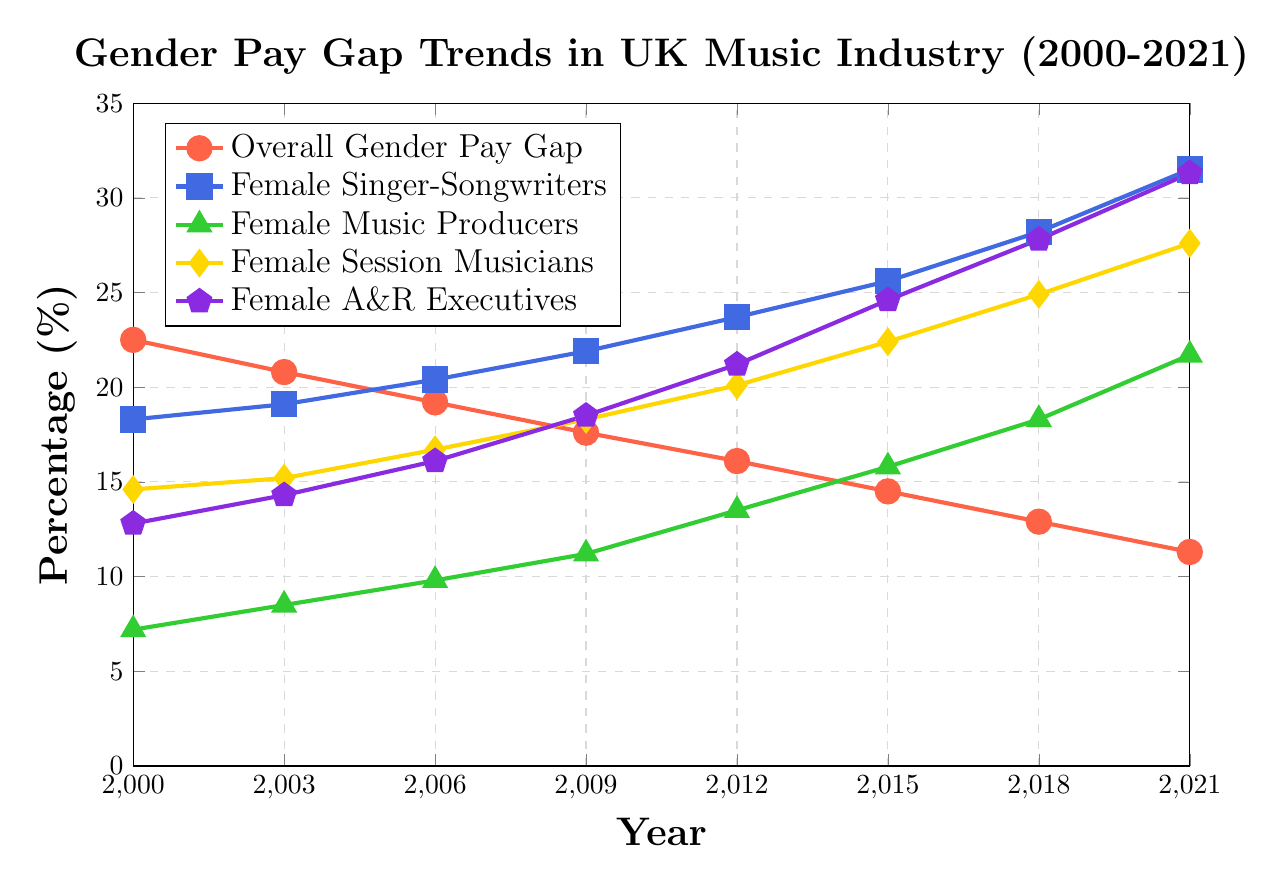What trend is observed for the Overall Gender Pay Gap from 2000 to 2021? The Overall Gender Pay Gap percentage is observed to decrease continuously from 22.5% in 2000 to 11.3% in 2021.
Answer: Decreasing trend How did the percentage of Female Music Producers change between 2000 and 2021? The percentage of Female Music Producers increased from 7.2% in 2000 to 21.7% in 2021.
Answer: Increased Compare the percentage of Female Singer-Songwriters and Female A&R Executives in 2021. Which category has a higher percentage? In 2021, the percentage of Female Singer-Songwriters is 31.5%, while the percentage of Female A&R Executives is 31.3%. Female Singer-Songwriters have a higher percentage.
Answer: Female Singer-Songwriters What is the difference in the percentage of Female Session Musicians between 2000 and 2021? The percentage of Female Session Musicians increased from 14.6% in 2000 to 27.6% in 2021. The difference is 27.6% - 14.6% = 13%.
Answer: 13% In which year did the percentage of Female A&R Executives exceed 20%? The percentage of Female A&R Executives first exceeded 20% in the year 2012.
Answer: 2012 Which category showed the largest increase in percentage from 2000 to 2021? To find the largest increase, calculate the difference for each category between 2000 and 2021:
- Female Singer-Songwriters: 31.5% - 18.3% = 13.2%
- Female Music Producers: 21.7% - 7.2% = 14.5%
- Female Session Musicians: 27.6% - 14.6% = 13%
- Female A&R Executives: 31.3% - 12.8% = 18.5%
The largest increase is for Female A&R Executives with an increase of 18.5%.
Answer: Female A&R Executives What is the average percentage of Female Singer-Songwriters for the years 2000, 2006, 2012, and 2018? Calculate the average by summing the percentages for the given years and dividing by the number of years: (18.3 + 20.4 + 23.7 + 28.2) / 4 = 22.65%.
Answer: 22.65% Between 2006 and 2009, which category showed the highest percentage growth? Calculate the percentage growth for each category between 2006 and 2009:
- Female Singer-Songwriters: 21.9% - 20.4% = 1.5%
- Female Music Producers: 11.2% - 9.8% = 1.4%
- Female Session Musicians: 18.3% - 16.7% = 1.6%
- Female A&R Executives: 18.5% - 16.1% = 2.4%
The highest percentage growth was in Female A&R Executives with 2.4%.
Answer: Female A&R Executives Which line is represented by the red color in the figure? The figure uses the red color to represent the Overall Gender Pay Gap.
Answer: Overall Gender Pay Gap What is the percentage difference between Female Singer-Songwriters and Female Music Producers in 2018? The percentage of Female Singer-Songwriters in 2018 is 28.2% and that of Female Music Producers is 18.3%. The difference is 28.2% - 18.3% = 9.9%.
Answer: 9.9% 